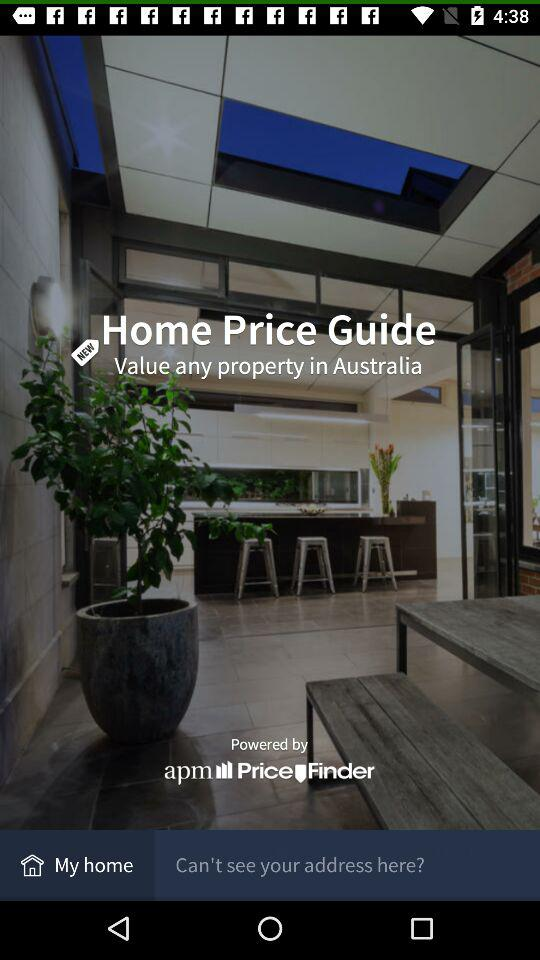What is the name of the application?
When the provided information is insufficient, respond with <no answer>. <no answer> 